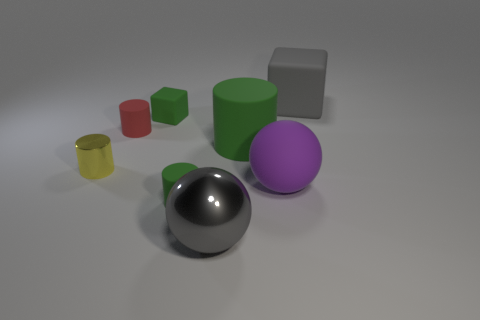Subtract 1 cylinders. How many cylinders are left? 3 Subtract all yellow cylinders. How many cylinders are left? 3 Subtract all matte cylinders. How many cylinders are left? 1 Add 1 large gray blocks. How many objects exist? 9 Subtract all blue cylinders. Subtract all yellow balls. How many cylinders are left? 4 Subtract all spheres. How many objects are left? 6 Subtract all tiny green rubber cylinders. Subtract all large gray metallic balls. How many objects are left? 6 Add 4 large cubes. How many large cubes are left? 5 Add 3 big gray spheres. How many big gray spheres exist? 4 Subtract 0 blue spheres. How many objects are left? 8 